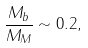Convert formula to latex. <formula><loc_0><loc_0><loc_500><loc_500>\frac { M _ { b } } { M _ { M } } \sim 0 . 2 ,</formula> 